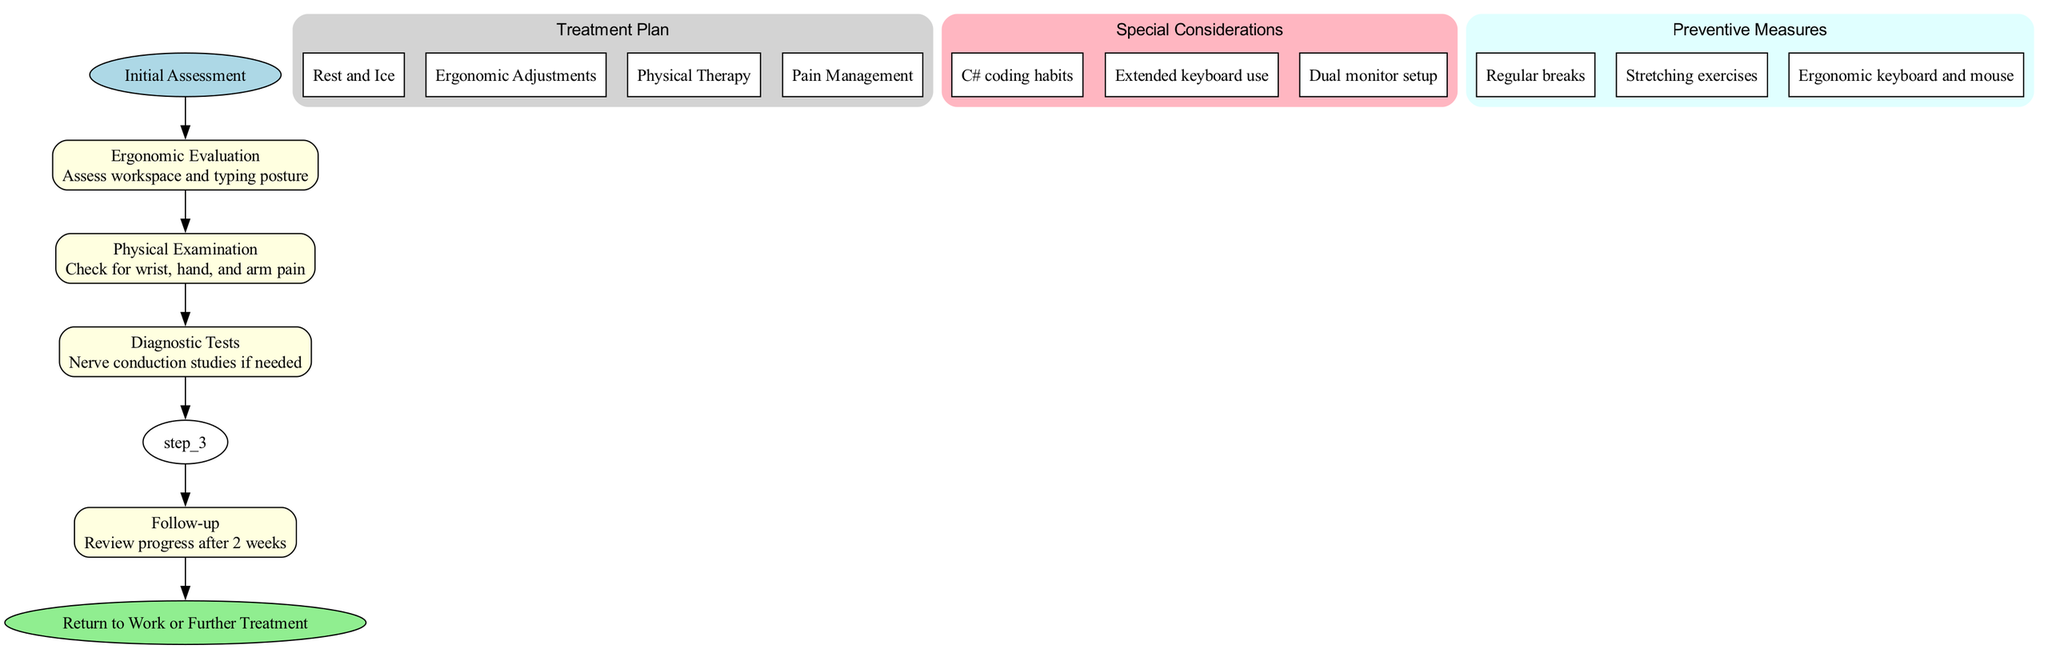What is the starting point of the clinical pathway? The starting point, labeled "Initial Assessment" in the diagram, indicates where the clinical pathway begins.
Answer: Initial Assessment How many steps are there in the pathway? The pathway consists of five steps listed in the diagram. Counting each step element provides the total number of steps.
Answer: 5 What is the first step in the pathway? The first step is identified as "Ergonomic Evaluation," which allows for understanding the initial actions taken in the pathway.
Answer: Ergonomic Evaluation What options are included in the Treatment Plan? The Treatment Plan node contains multiple options. Identifying these from the diagram shows that the options are Rest and Ice, Ergonomic Adjustments, Physical Therapy, and Pain Management.
Answer: Rest and Ice, Ergonomic Adjustments, Physical Therapy, Pain Management What are the special considerations highlighted in the pathway? The diagram specifies three special considerations related to working habits, indicating that C# coding habits, extended keyboard use, and dual monitor setup are all factors that may influence treatment.
Answer: C# coding habits, Extended keyboard use, Dual monitor setup What preventive measures are advised in the pathway? Identifying the preventive measures from the diagram reveals that Regular breaks, Stretching exercises, and Ergonomic keyboard and mouse are included.
Answer: Regular breaks, Stretching exercises, Ergonomic keyboard and mouse What happens after the Treatment Plan step? Following the Treatment Plan step, the process leads to a Follow-up step where the progress is reviewed after two weeks. This relationship clarifies the sequence of steps in the pathway.
Answer: Follow-up What is the endpoint of the clinical pathway? The endpoint, indicated in the diagram, concludes the clinical pathway with the option of either returning to work or seeking further treatment.
Answer: Return to Work or Further Treatment Which step involves checking for pain? The step titled "Physical Examination" is the one that involves checking for wrist, hand, and arm pain, as indicated in the description of that step.
Answer: Physical Examination How many preventive measures are mentioned? There are three preventive measures listed in the diagram, which can be counted directly from the respective node.
Answer: 3 